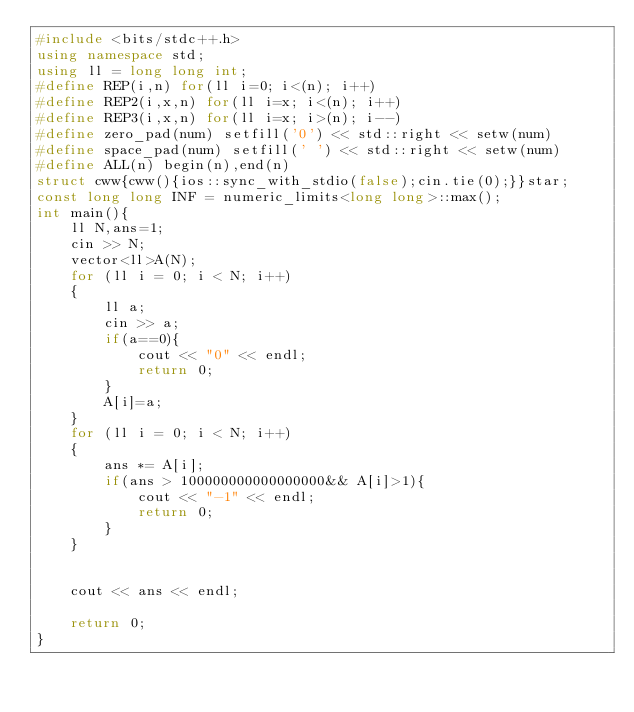<code> <loc_0><loc_0><loc_500><loc_500><_C++_>#include <bits/stdc++.h>
using namespace std;
using ll = long long int;
#define REP(i,n) for(ll i=0; i<(n); i++)
#define REP2(i,x,n) for(ll i=x; i<(n); i++)
#define REP3(i,x,n) for(ll i=x; i>(n); i--)
#define zero_pad(num) setfill('0') << std::right << setw(num)
#define space_pad(num) setfill(' ') << std::right << setw(num)
#define ALL(n) begin(n),end(n)
struct cww{cww(){ios::sync_with_stdio(false);cin.tie(0);}}star;
const long long INF = numeric_limits<long long>::max();
int main(){
    ll N,ans=1;
    cin >> N;
    vector<ll>A(N);
    for (ll i = 0; i < N; i++)
    {
        ll a;
        cin >> a;
        if(a==0){
            cout << "0" << endl;
            return 0;
        }
        A[i]=a;
    }
    for (ll i = 0; i < N; i++)
    {
        ans *= A[i];
        if(ans > 100000000000000000&& A[i]>1){
            cout << "-1" << endl;
            return 0;
        }
    }
    
    
    cout << ans << endl;
    
    return 0;
}
</code> 